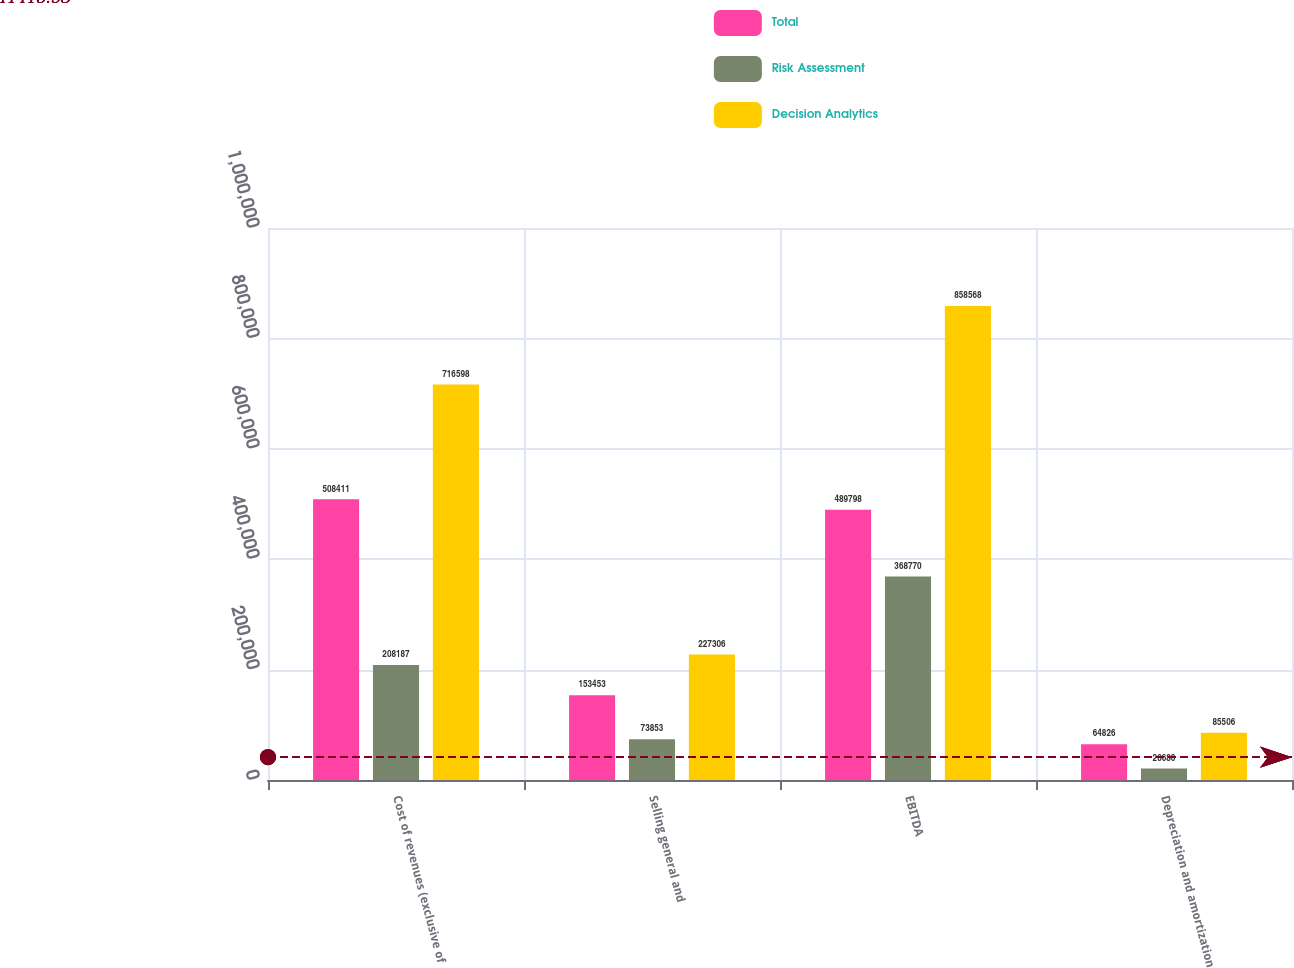<chart> <loc_0><loc_0><loc_500><loc_500><stacked_bar_chart><ecel><fcel>Cost of revenues (exclusive of<fcel>Selling general and<fcel>EBITDA<fcel>Depreciation and amortization<nl><fcel>Total<fcel>508411<fcel>153453<fcel>489798<fcel>64826<nl><fcel>Risk Assessment<fcel>208187<fcel>73853<fcel>368770<fcel>20680<nl><fcel>Decision Analytics<fcel>716598<fcel>227306<fcel>858568<fcel>85506<nl></chart> 